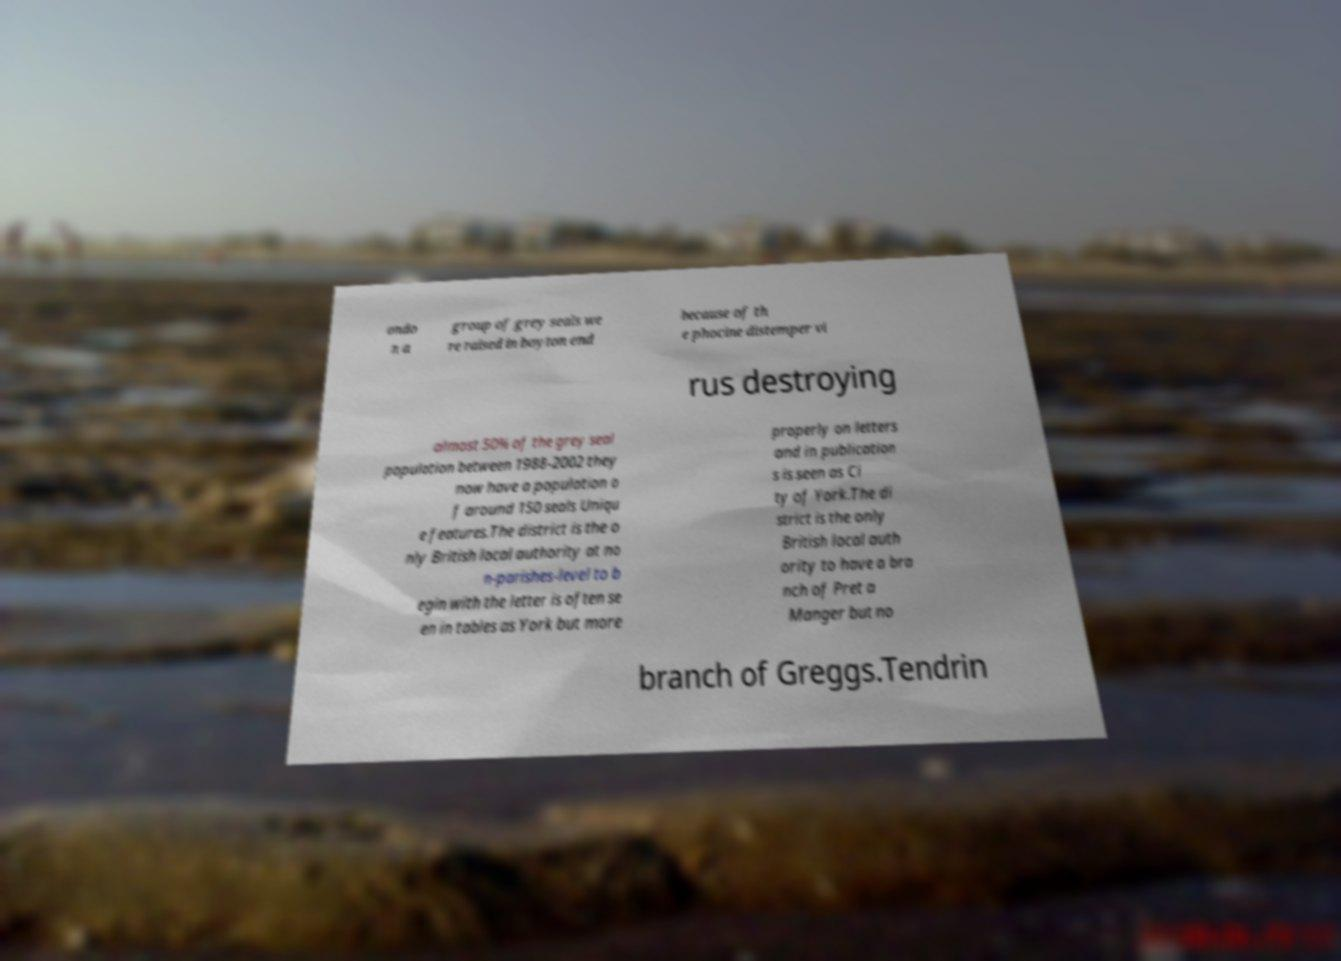There's text embedded in this image that I need extracted. Can you transcribe it verbatim? ondo n a group of grey seals we re raised in boyton end because of th e phocine distemper vi rus destroying almost 50% of the grey seal population between 1988-2002 they now have a population o f around 150 seals Uniqu e features.The district is the o nly British local authority at no n-parishes-level to b egin with the letter is often se en in tables as York but more properly on letters and in publication s is seen as Ci ty of York.The di strict is the only British local auth ority to have a bra nch of Pret a Manger but no branch of Greggs.Tendrin 